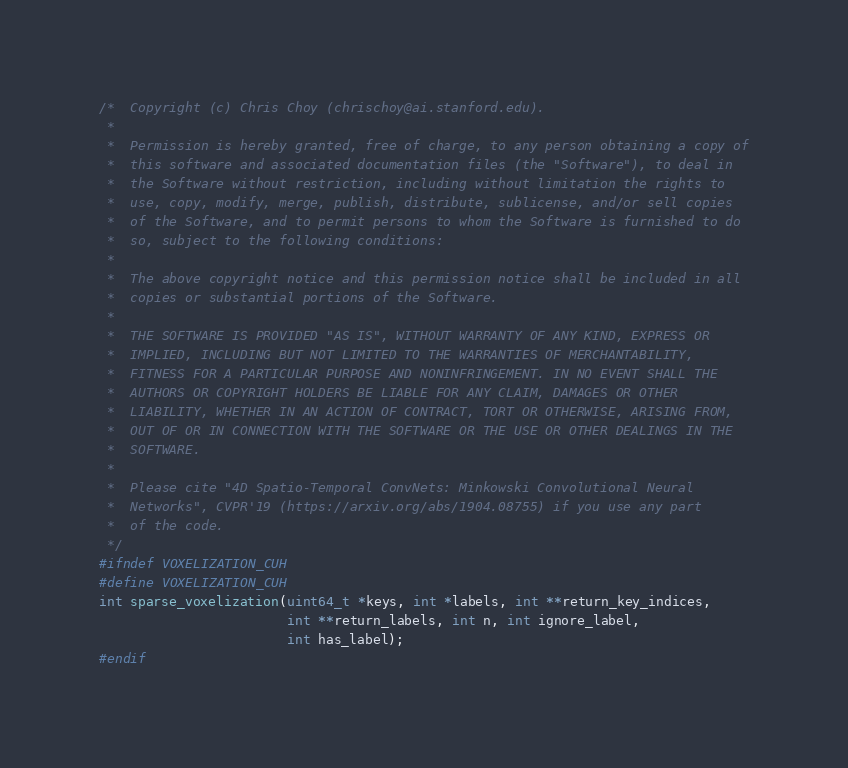Convert code to text. <code><loc_0><loc_0><loc_500><loc_500><_Cuda_>/*  Copyright (c) Chris Choy (chrischoy@ai.stanford.edu).
 *
 *  Permission is hereby granted, free of charge, to any person obtaining a copy of
 *  this software and associated documentation files (the "Software"), to deal in
 *  the Software without restriction, including without limitation the rights to
 *  use, copy, modify, merge, publish, distribute, sublicense, and/or sell copies
 *  of the Software, and to permit persons to whom the Software is furnished to do
 *  so, subject to the following conditions:
 *
 *  The above copyright notice and this permission notice shall be included in all
 *  copies or substantial portions of the Software.
 *
 *  THE SOFTWARE IS PROVIDED "AS IS", WITHOUT WARRANTY OF ANY KIND, EXPRESS OR
 *  IMPLIED, INCLUDING BUT NOT LIMITED TO THE WARRANTIES OF MERCHANTABILITY,
 *  FITNESS FOR A PARTICULAR PURPOSE AND NONINFRINGEMENT. IN NO EVENT SHALL THE
 *  AUTHORS OR COPYRIGHT HOLDERS BE LIABLE FOR ANY CLAIM, DAMAGES OR OTHER
 *  LIABILITY, WHETHER IN AN ACTION OF CONTRACT, TORT OR OTHERWISE, ARISING FROM,
 *  OUT OF OR IN CONNECTION WITH THE SOFTWARE OR THE USE OR OTHER DEALINGS IN THE
 *  SOFTWARE.
 *
 *  Please cite "4D Spatio-Temporal ConvNets: Minkowski Convolutional Neural
 *  Networks", CVPR'19 (https://arxiv.org/abs/1904.08755) if you use any part
 *  of the code.
 */
#ifndef VOXELIZATION_CUH
#define VOXELIZATION_CUH
int sparse_voxelization(uint64_t *keys, int *labels, int **return_key_indices,
                        int **return_labels, int n, int ignore_label,
                        int has_label);
#endif
</code> 